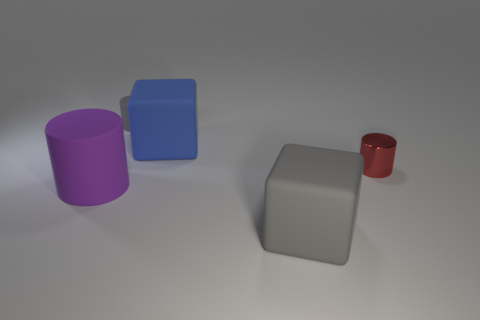There is a purple cylinder that is the same size as the blue cube; what is its material?
Ensure brevity in your answer.  Rubber. What number of things are the same color as the tiny rubber cylinder?
Provide a short and direct response. 1. How many things are tiny things that are in front of the gray cylinder or tiny cylinders that are behind the metal cylinder?
Provide a succinct answer. 2. What number of other objects are the same shape as the red object?
Keep it short and to the point. 2. Do the thing in front of the purple rubber cylinder and the tiny rubber object have the same color?
Your response must be concise. Yes. What number of other objects are the same size as the red metal thing?
Your response must be concise. 1. Does the blue thing have the same material as the purple cylinder?
Provide a short and direct response. Yes. What is the color of the small matte cylinder that is behind the matte thing on the left side of the small gray matte cylinder?
Keep it short and to the point. Gray. There is another gray object that is the same shape as the tiny metal object; what size is it?
Offer a terse response. Small. There is a rubber block in front of the cylinder that is in front of the red cylinder; what number of tiny things are on the left side of it?
Provide a short and direct response. 1. 